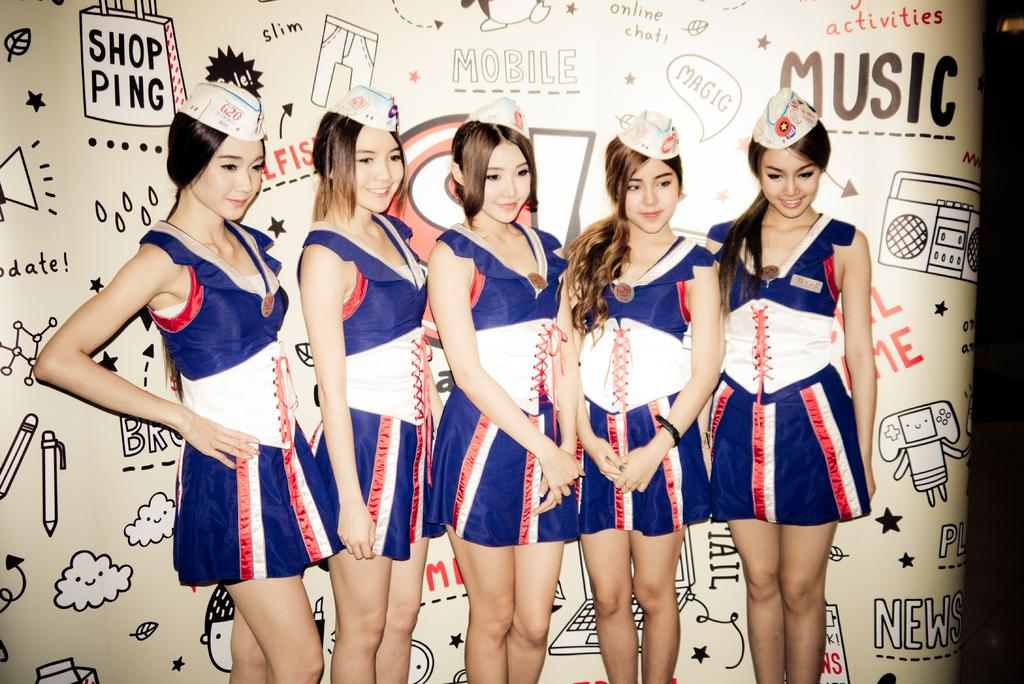<image>
Summarize the visual content of the image. five young female cheerleaders for Shop Ping Music 